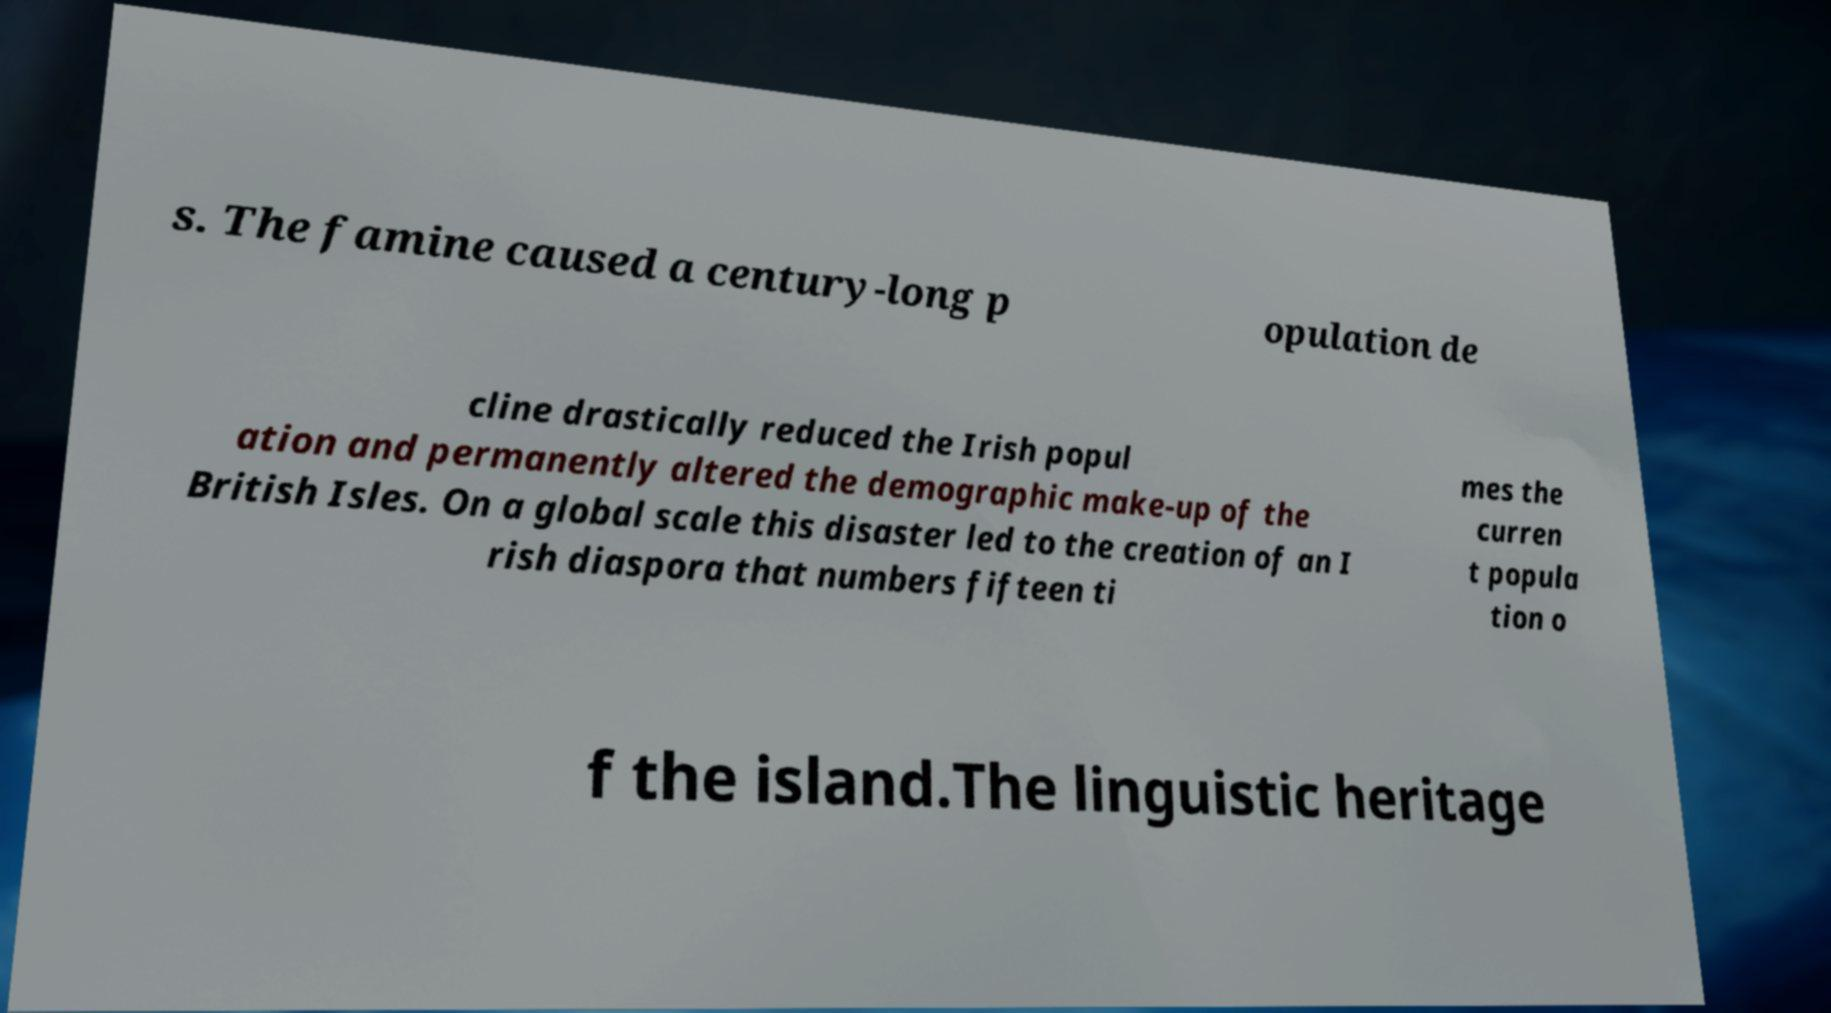I need the written content from this picture converted into text. Can you do that? s. The famine caused a century-long p opulation de cline drastically reduced the Irish popul ation and permanently altered the demographic make-up of the British Isles. On a global scale this disaster led to the creation of an I rish diaspora that numbers fifteen ti mes the curren t popula tion o f the island.The linguistic heritage 